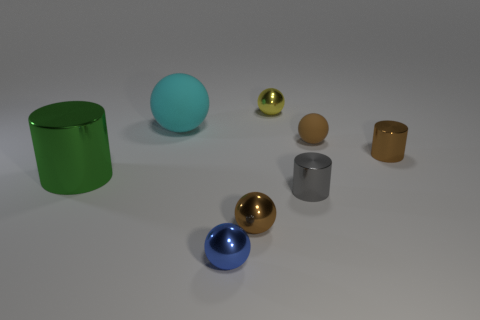Subtract all small rubber spheres. How many spheres are left? 4 Subtract all yellow spheres. How many spheres are left? 4 Subtract 1 balls. How many balls are left? 4 Subtract all cyan spheres. Subtract all cyan cylinders. How many spheres are left? 4 Add 1 big cylinders. How many objects exist? 9 Subtract all balls. How many objects are left? 3 Add 4 tiny yellow things. How many tiny yellow things are left? 5 Add 2 tiny yellow cylinders. How many tiny yellow cylinders exist? 2 Subtract 0 purple cylinders. How many objects are left? 8 Subtract all tiny metal cylinders. Subtract all tiny metallic objects. How many objects are left? 1 